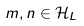<formula> <loc_0><loc_0><loc_500><loc_500>m , n \in { \mathcal { H } } _ { L }</formula> 